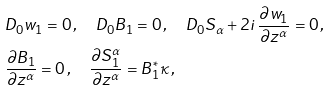Convert formula to latex. <formula><loc_0><loc_0><loc_500><loc_500>& D _ { 0 } w _ { 1 } = 0 \, , \quad D _ { 0 } B _ { 1 } = 0 \, , \quad D _ { 0 } S _ { \alpha } + 2 i \, \frac { \partial w _ { 1 } } { \partial z ^ { \alpha } } = 0 \, , \\ & \frac { \partial B _ { 1 } } { \partial z ^ { \alpha } } = 0 \, , \quad \frac { \partial S _ { 1 } ^ { \alpha } } { \partial z ^ { \alpha } } = B _ { 1 } ^ { * } \kappa \, ,</formula> 